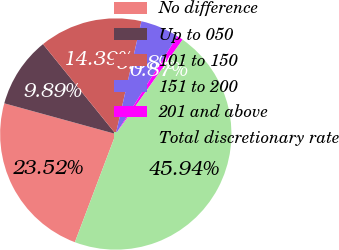Convert chart to OTSL. <chart><loc_0><loc_0><loc_500><loc_500><pie_chart><fcel>No difference<fcel>Up to 050<fcel>101 to 150<fcel>151 to 200<fcel>201 and above<fcel>Total discretionary rate<nl><fcel>23.52%<fcel>9.89%<fcel>14.39%<fcel>5.38%<fcel>0.87%<fcel>45.94%<nl></chart> 